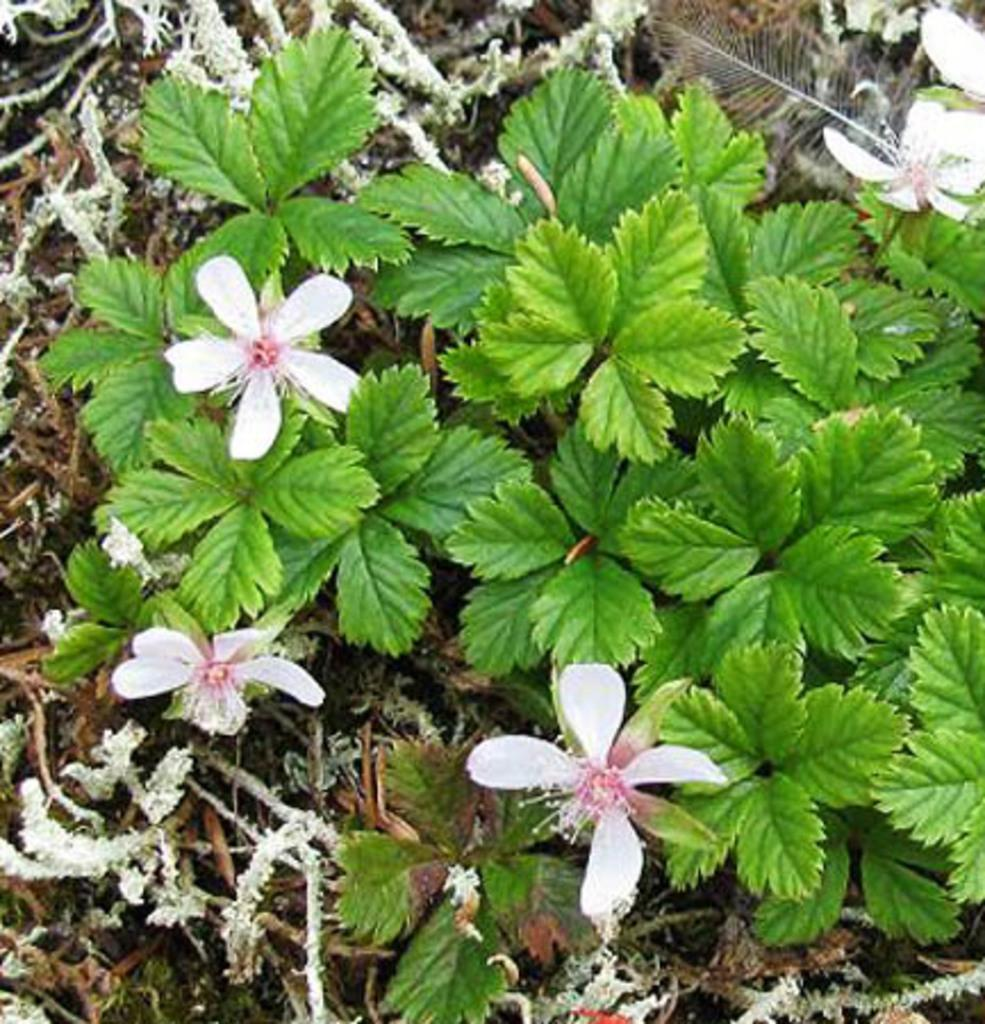What type of vegetation can be seen on the ground in the image? There are plants on the ground in the image. What additional features can be observed on the plants? Flowers are present on the plants in the image. Where is the kitty sitting in the image? There is no kitty present in the image. 